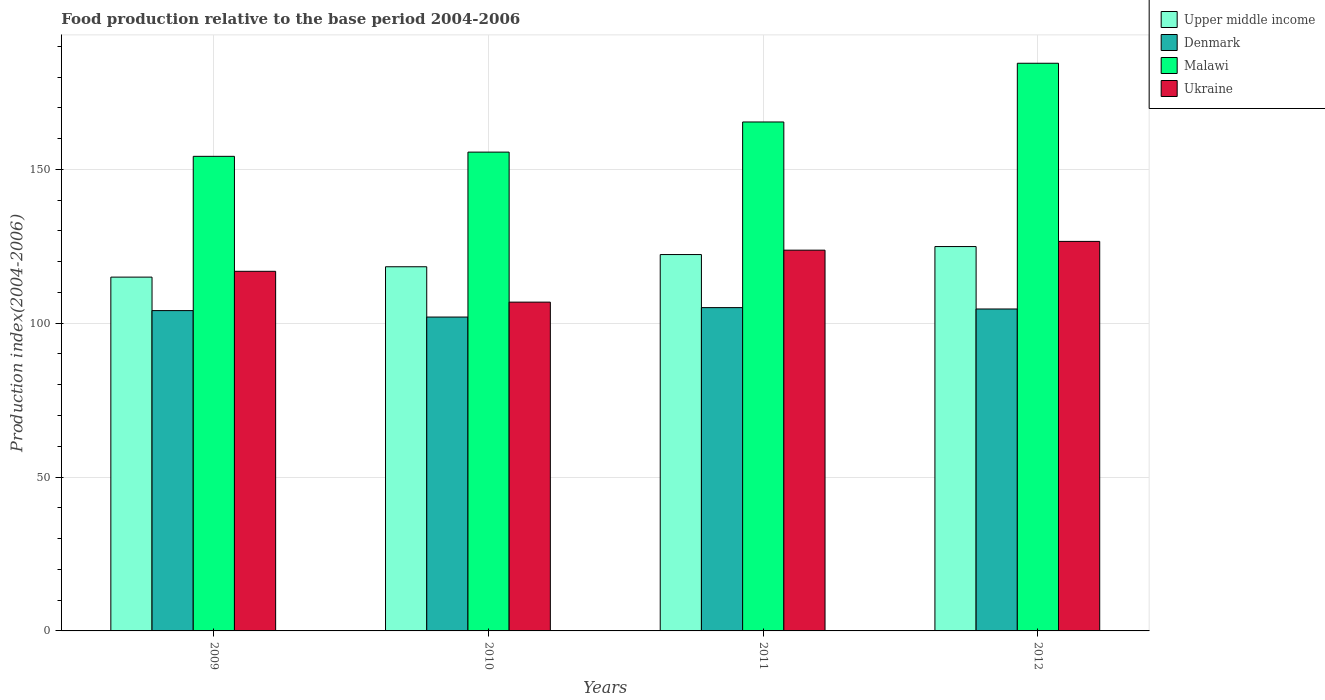How many different coloured bars are there?
Make the answer very short. 4. Are the number of bars per tick equal to the number of legend labels?
Your answer should be compact. Yes. How many bars are there on the 4th tick from the left?
Make the answer very short. 4. What is the label of the 3rd group of bars from the left?
Your answer should be very brief. 2011. What is the food production index in Denmark in 2010?
Your answer should be very brief. 102. Across all years, what is the maximum food production index in Malawi?
Give a very brief answer. 184.48. Across all years, what is the minimum food production index in Ukraine?
Provide a succinct answer. 106.85. In which year was the food production index in Denmark maximum?
Keep it short and to the point. 2011. What is the total food production index in Denmark in the graph?
Offer a very short reply. 415.79. What is the difference between the food production index in Upper middle income in 2009 and that in 2010?
Your response must be concise. -3.37. What is the difference between the food production index in Denmark in 2011 and the food production index in Ukraine in 2012?
Your answer should be compact. -21.52. What is the average food production index in Malawi per year?
Provide a short and direct response. 164.93. In the year 2009, what is the difference between the food production index in Denmark and food production index in Malawi?
Offer a terse response. -50.13. In how many years, is the food production index in Denmark greater than 160?
Keep it short and to the point. 0. What is the ratio of the food production index in Malawi in 2009 to that in 2010?
Offer a very short reply. 0.99. Is the food production index in Upper middle income in 2009 less than that in 2012?
Provide a succinct answer. Yes. What is the difference between the highest and the second highest food production index in Denmark?
Offer a terse response. 0.45. What is the difference between the highest and the lowest food production index in Denmark?
Offer a very short reply. 3.07. In how many years, is the food production index in Denmark greater than the average food production index in Denmark taken over all years?
Provide a succinct answer. 3. Is the sum of the food production index in Ukraine in 2009 and 2011 greater than the maximum food production index in Denmark across all years?
Your response must be concise. Yes. What does the 1st bar from the left in 2012 represents?
Provide a short and direct response. Upper middle income. What does the 1st bar from the right in 2010 represents?
Keep it short and to the point. Ukraine. Is it the case that in every year, the sum of the food production index in Upper middle income and food production index in Malawi is greater than the food production index in Ukraine?
Offer a very short reply. Yes. How many years are there in the graph?
Offer a terse response. 4. Are the values on the major ticks of Y-axis written in scientific E-notation?
Provide a succinct answer. No. Does the graph contain any zero values?
Provide a short and direct response. No. Where does the legend appear in the graph?
Offer a terse response. Top right. How many legend labels are there?
Ensure brevity in your answer.  4. What is the title of the graph?
Your answer should be compact. Food production relative to the base period 2004-2006. Does "Jamaica" appear as one of the legend labels in the graph?
Make the answer very short. No. What is the label or title of the X-axis?
Your answer should be compact. Years. What is the label or title of the Y-axis?
Provide a succinct answer. Production index(2004-2006). What is the Production index(2004-2006) of Upper middle income in 2009?
Offer a terse response. 114.98. What is the Production index(2004-2006) in Denmark in 2009?
Your answer should be compact. 104.1. What is the Production index(2004-2006) of Malawi in 2009?
Your answer should be very brief. 154.23. What is the Production index(2004-2006) in Ukraine in 2009?
Offer a terse response. 116.87. What is the Production index(2004-2006) in Upper middle income in 2010?
Make the answer very short. 118.35. What is the Production index(2004-2006) in Denmark in 2010?
Offer a terse response. 102. What is the Production index(2004-2006) of Malawi in 2010?
Offer a very short reply. 155.6. What is the Production index(2004-2006) of Ukraine in 2010?
Give a very brief answer. 106.85. What is the Production index(2004-2006) of Upper middle income in 2011?
Give a very brief answer. 122.31. What is the Production index(2004-2006) of Denmark in 2011?
Offer a terse response. 105.07. What is the Production index(2004-2006) of Malawi in 2011?
Provide a short and direct response. 165.4. What is the Production index(2004-2006) in Ukraine in 2011?
Your answer should be very brief. 123.74. What is the Production index(2004-2006) in Upper middle income in 2012?
Provide a short and direct response. 124.91. What is the Production index(2004-2006) in Denmark in 2012?
Offer a terse response. 104.62. What is the Production index(2004-2006) in Malawi in 2012?
Provide a succinct answer. 184.48. What is the Production index(2004-2006) in Ukraine in 2012?
Provide a short and direct response. 126.59. Across all years, what is the maximum Production index(2004-2006) of Upper middle income?
Your response must be concise. 124.91. Across all years, what is the maximum Production index(2004-2006) in Denmark?
Ensure brevity in your answer.  105.07. Across all years, what is the maximum Production index(2004-2006) in Malawi?
Your response must be concise. 184.48. Across all years, what is the maximum Production index(2004-2006) in Ukraine?
Offer a terse response. 126.59. Across all years, what is the minimum Production index(2004-2006) of Upper middle income?
Provide a succinct answer. 114.98. Across all years, what is the minimum Production index(2004-2006) in Denmark?
Your answer should be very brief. 102. Across all years, what is the minimum Production index(2004-2006) in Malawi?
Offer a terse response. 154.23. Across all years, what is the minimum Production index(2004-2006) of Ukraine?
Provide a short and direct response. 106.85. What is the total Production index(2004-2006) of Upper middle income in the graph?
Make the answer very short. 480.55. What is the total Production index(2004-2006) of Denmark in the graph?
Ensure brevity in your answer.  415.79. What is the total Production index(2004-2006) in Malawi in the graph?
Your answer should be compact. 659.71. What is the total Production index(2004-2006) in Ukraine in the graph?
Ensure brevity in your answer.  474.05. What is the difference between the Production index(2004-2006) in Upper middle income in 2009 and that in 2010?
Ensure brevity in your answer.  -3.37. What is the difference between the Production index(2004-2006) in Denmark in 2009 and that in 2010?
Provide a succinct answer. 2.1. What is the difference between the Production index(2004-2006) of Malawi in 2009 and that in 2010?
Give a very brief answer. -1.37. What is the difference between the Production index(2004-2006) of Ukraine in 2009 and that in 2010?
Your answer should be very brief. 10.02. What is the difference between the Production index(2004-2006) in Upper middle income in 2009 and that in 2011?
Offer a very short reply. -7.33. What is the difference between the Production index(2004-2006) in Denmark in 2009 and that in 2011?
Give a very brief answer. -0.97. What is the difference between the Production index(2004-2006) in Malawi in 2009 and that in 2011?
Offer a terse response. -11.17. What is the difference between the Production index(2004-2006) of Ukraine in 2009 and that in 2011?
Your answer should be very brief. -6.87. What is the difference between the Production index(2004-2006) of Upper middle income in 2009 and that in 2012?
Your response must be concise. -9.93. What is the difference between the Production index(2004-2006) in Denmark in 2009 and that in 2012?
Provide a succinct answer. -0.52. What is the difference between the Production index(2004-2006) of Malawi in 2009 and that in 2012?
Give a very brief answer. -30.25. What is the difference between the Production index(2004-2006) of Ukraine in 2009 and that in 2012?
Provide a short and direct response. -9.72. What is the difference between the Production index(2004-2006) of Upper middle income in 2010 and that in 2011?
Make the answer very short. -3.96. What is the difference between the Production index(2004-2006) in Denmark in 2010 and that in 2011?
Provide a short and direct response. -3.07. What is the difference between the Production index(2004-2006) of Malawi in 2010 and that in 2011?
Provide a short and direct response. -9.8. What is the difference between the Production index(2004-2006) in Ukraine in 2010 and that in 2011?
Give a very brief answer. -16.89. What is the difference between the Production index(2004-2006) of Upper middle income in 2010 and that in 2012?
Provide a succinct answer. -6.57. What is the difference between the Production index(2004-2006) in Denmark in 2010 and that in 2012?
Ensure brevity in your answer.  -2.62. What is the difference between the Production index(2004-2006) of Malawi in 2010 and that in 2012?
Your answer should be very brief. -28.88. What is the difference between the Production index(2004-2006) in Ukraine in 2010 and that in 2012?
Provide a short and direct response. -19.74. What is the difference between the Production index(2004-2006) in Upper middle income in 2011 and that in 2012?
Your answer should be compact. -2.6. What is the difference between the Production index(2004-2006) of Denmark in 2011 and that in 2012?
Make the answer very short. 0.45. What is the difference between the Production index(2004-2006) in Malawi in 2011 and that in 2012?
Your response must be concise. -19.08. What is the difference between the Production index(2004-2006) of Ukraine in 2011 and that in 2012?
Offer a very short reply. -2.85. What is the difference between the Production index(2004-2006) of Upper middle income in 2009 and the Production index(2004-2006) of Denmark in 2010?
Your answer should be compact. 12.98. What is the difference between the Production index(2004-2006) in Upper middle income in 2009 and the Production index(2004-2006) in Malawi in 2010?
Keep it short and to the point. -40.62. What is the difference between the Production index(2004-2006) in Upper middle income in 2009 and the Production index(2004-2006) in Ukraine in 2010?
Give a very brief answer. 8.13. What is the difference between the Production index(2004-2006) in Denmark in 2009 and the Production index(2004-2006) in Malawi in 2010?
Your answer should be very brief. -51.5. What is the difference between the Production index(2004-2006) of Denmark in 2009 and the Production index(2004-2006) of Ukraine in 2010?
Offer a very short reply. -2.75. What is the difference between the Production index(2004-2006) in Malawi in 2009 and the Production index(2004-2006) in Ukraine in 2010?
Offer a very short reply. 47.38. What is the difference between the Production index(2004-2006) in Upper middle income in 2009 and the Production index(2004-2006) in Denmark in 2011?
Your response must be concise. 9.91. What is the difference between the Production index(2004-2006) in Upper middle income in 2009 and the Production index(2004-2006) in Malawi in 2011?
Provide a succinct answer. -50.42. What is the difference between the Production index(2004-2006) in Upper middle income in 2009 and the Production index(2004-2006) in Ukraine in 2011?
Offer a very short reply. -8.76. What is the difference between the Production index(2004-2006) of Denmark in 2009 and the Production index(2004-2006) of Malawi in 2011?
Make the answer very short. -61.3. What is the difference between the Production index(2004-2006) of Denmark in 2009 and the Production index(2004-2006) of Ukraine in 2011?
Give a very brief answer. -19.64. What is the difference between the Production index(2004-2006) in Malawi in 2009 and the Production index(2004-2006) in Ukraine in 2011?
Offer a terse response. 30.49. What is the difference between the Production index(2004-2006) in Upper middle income in 2009 and the Production index(2004-2006) in Denmark in 2012?
Provide a short and direct response. 10.36. What is the difference between the Production index(2004-2006) of Upper middle income in 2009 and the Production index(2004-2006) of Malawi in 2012?
Your response must be concise. -69.5. What is the difference between the Production index(2004-2006) in Upper middle income in 2009 and the Production index(2004-2006) in Ukraine in 2012?
Keep it short and to the point. -11.61. What is the difference between the Production index(2004-2006) of Denmark in 2009 and the Production index(2004-2006) of Malawi in 2012?
Keep it short and to the point. -80.38. What is the difference between the Production index(2004-2006) of Denmark in 2009 and the Production index(2004-2006) of Ukraine in 2012?
Give a very brief answer. -22.49. What is the difference between the Production index(2004-2006) of Malawi in 2009 and the Production index(2004-2006) of Ukraine in 2012?
Ensure brevity in your answer.  27.64. What is the difference between the Production index(2004-2006) in Upper middle income in 2010 and the Production index(2004-2006) in Denmark in 2011?
Make the answer very short. 13.28. What is the difference between the Production index(2004-2006) of Upper middle income in 2010 and the Production index(2004-2006) of Malawi in 2011?
Your response must be concise. -47.05. What is the difference between the Production index(2004-2006) of Upper middle income in 2010 and the Production index(2004-2006) of Ukraine in 2011?
Offer a very short reply. -5.39. What is the difference between the Production index(2004-2006) of Denmark in 2010 and the Production index(2004-2006) of Malawi in 2011?
Keep it short and to the point. -63.4. What is the difference between the Production index(2004-2006) of Denmark in 2010 and the Production index(2004-2006) of Ukraine in 2011?
Offer a very short reply. -21.74. What is the difference between the Production index(2004-2006) of Malawi in 2010 and the Production index(2004-2006) of Ukraine in 2011?
Give a very brief answer. 31.86. What is the difference between the Production index(2004-2006) in Upper middle income in 2010 and the Production index(2004-2006) in Denmark in 2012?
Your response must be concise. 13.73. What is the difference between the Production index(2004-2006) of Upper middle income in 2010 and the Production index(2004-2006) of Malawi in 2012?
Your response must be concise. -66.13. What is the difference between the Production index(2004-2006) of Upper middle income in 2010 and the Production index(2004-2006) of Ukraine in 2012?
Ensure brevity in your answer.  -8.24. What is the difference between the Production index(2004-2006) in Denmark in 2010 and the Production index(2004-2006) in Malawi in 2012?
Give a very brief answer. -82.48. What is the difference between the Production index(2004-2006) of Denmark in 2010 and the Production index(2004-2006) of Ukraine in 2012?
Provide a short and direct response. -24.59. What is the difference between the Production index(2004-2006) of Malawi in 2010 and the Production index(2004-2006) of Ukraine in 2012?
Offer a terse response. 29.01. What is the difference between the Production index(2004-2006) of Upper middle income in 2011 and the Production index(2004-2006) of Denmark in 2012?
Provide a short and direct response. 17.69. What is the difference between the Production index(2004-2006) in Upper middle income in 2011 and the Production index(2004-2006) in Malawi in 2012?
Offer a very short reply. -62.17. What is the difference between the Production index(2004-2006) in Upper middle income in 2011 and the Production index(2004-2006) in Ukraine in 2012?
Provide a succinct answer. -4.28. What is the difference between the Production index(2004-2006) of Denmark in 2011 and the Production index(2004-2006) of Malawi in 2012?
Keep it short and to the point. -79.41. What is the difference between the Production index(2004-2006) of Denmark in 2011 and the Production index(2004-2006) of Ukraine in 2012?
Give a very brief answer. -21.52. What is the difference between the Production index(2004-2006) of Malawi in 2011 and the Production index(2004-2006) of Ukraine in 2012?
Give a very brief answer. 38.81. What is the average Production index(2004-2006) in Upper middle income per year?
Your answer should be very brief. 120.14. What is the average Production index(2004-2006) of Denmark per year?
Provide a succinct answer. 103.95. What is the average Production index(2004-2006) in Malawi per year?
Your answer should be compact. 164.93. What is the average Production index(2004-2006) of Ukraine per year?
Keep it short and to the point. 118.51. In the year 2009, what is the difference between the Production index(2004-2006) of Upper middle income and Production index(2004-2006) of Denmark?
Offer a very short reply. 10.88. In the year 2009, what is the difference between the Production index(2004-2006) in Upper middle income and Production index(2004-2006) in Malawi?
Provide a short and direct response. -39.25. In the year 2009, what is the difference between the Production index(2004-2006) of Upper middle income and Production index(2004-2006) of Ukraine?
Your answer should be compact. -1.89. In the year 2009, what is the difference between the Production index(2004-2006) of Denmark and Production index(2004-2006) of Malawi?
Provide a short and direct response. -50.13. In the year 2009, what is the difference between the Production index(2004-2006) of Denmark and Production index(2004-2006) of Ukraine?
Keep it short and to the point. -12.77. In the year 2009, what is the difference between the Production index(2004-2006) of Malawi and Production index(2004-2006) of Ukraine?
Ensure brevity in your answer.  37.36. In the year 2010, what is the difference between the Production index(2004-2006) in Upper middle income and Production index(2004-2006) in Denmark?
Offer a terse response. 16.35. In the year 2010, what is the difference between the Production index(2004-2006) in Upper middle income and Production index(2004-2006) in Malawi?
Give a very brief answer. -37.25. In the year 2010, what is the difference between the Production index(2004-2006) in Upper middle income and Production index(2004-2006) in Ukraine?
Your answer should be very brief. 11.5. In the year 2010, what is the difference between the Production index(2004-2006) in Denmark and Production index(2004-2006) in Malawi?
Your answer should be compact. -53.6. In the year 2010, what is the difference between the Production index(2004-2006) of Denmark and Production index(2004-2006) of Ukraine?
Your answer should be very brief. -4.85. In the year 2010, what is the difference between the Production index(2004-2006) in Malawi and Production index(2004-2006) in Ukraine?
Give a very brief answer. 48.75. In the year 2011, what is the difference between the Production index(2004-2006) of Upper middle income and Production index(2004-2006) of Denmark?
Your answer should be compact. 17.24. In the year 2011, what is the difference between the Production index(2004-2006) of Upper middle income and Production index(2004-2006) of Malawi?
Offer a very short reply. -43.09. In the year 2011, what is the difference between the Production index(2004-2006) of Upper middle income and Production index(2004-2006) of Ukraine?
Give a very brief answer. -1.43. In the year 2011, what is the difference between the Production index(2004-2006) in Denmark and Production index(2004-2006) in Malawi?
Offer a terse response. -60.33. In the year 2011, what is the difference between the Production index(2004-2006) in Denmark and Production index(2004-2006) in Ukraine?
Give a very brief answer. -18.67. In the year 2011, what is the difference between the Production index(2004-2006) in Malawi and Production index(2004-2006) in Ukraine?
Give a very brief answer. 41.66. In the year 2012, what is the difference between the Production index(2004-2006) of Upper middle income and Production index(2004-2006) of Denmark?
Your response must be concise. 20.29. In the year 2012, what is the difference between the Production index(2004-2006) in Upper middle income and Production index(2004-2006) in Malawi?
Your response must be concise. -59.57. In the year 2012, what is the difference between the Production index(2004-2006) in Upper middle income and Production index(2004-2006) in Ukraine?
Offer a terse response. -1.68. In the year 2012, what is the difference between the Production index(2004-2006) in Denmark and Production index(2004-2006) in Malawi?
Your answer should be compact. -79.86. In the year 2012, what is the difference between the Production index(2004-2006) in Denmark and Production index(2004-2006) in Ukraine?
Offer a very short reply. -21.97. In the year 2012, what is the difference between the Production index(2004-2006) of Malawi and Production index(2004-2006) of Ukraine?
Give a very brief answer. 57.89. What is the ratio of the Production index(2004-2006) in Upper middle income in 2009 to that in 2010?
Ensure brevity in your answer.  0.97. What is the ratio of the Production index(2004-2006) of Denmark in 2009 to that in 2010?
Your response must be concise. 1.02. What is the ratio of the Production index(2004-2006) in Ukraine in 2009 to that in 2010?
Ensure brevity in your answer.  1.09. What is the ratio of the Production index(2004-2006) of Upper middle income in 2009 to that in 2011?
Offer a terse response. 0.94. What is the ratio of the Production index(2004-2006) of Denmark in 2009 to that in 2011?
Offer a very short reply. 0.99. What is the ratio of the Production index(2004-2006) in Malawi in 2009 to that in 2011?
Your answer should be compact. 0.93. What is the ratio of the Production index(2004-2006) in Ukraine in 2009 to that in 2011?
Your answer should be very brief. 0.94. What is the ratio of the Production index(2004-2006) in Upper middle income in 2009 to that in 2012?
Ensure brevity in your answer.  0.92. What is the ratio of the Production index(2004-2006) of Malawi in 2009 to that in 2012?
Offer a very short reply. 0.84. What is the ratio of the Production index(2004-2006) of Ukraine in 2009 to that in 2012?
Your answer should be compact. 0.92. What is the ratio of the Production index(2004-2006) in Upper middle income in 2010 to that in 2011?
Your answer should be very brief. 0.97. What is the ratio of the Production index(2004-2006) in Denmark in 2010 to that in 2011?
Offer a terse response. 0.97. What is the ratio of the Production index(2004-2006) of Malawi in 2010 to that in 2011?
Give a very brief answer. 0.94. What is the ratio of the Production index(2004-2006) of Ukraine in 2010 to that in 2011?
Provide a short and direct response. 0.86. What is the ratio of the Production index(2004-2006) of Upper middle income in 2010 to that in 2012?
Give a very brief answer. 0.95. What is the ratio of the Production index(2004-2006) of Denmark in 2010 to that in 2012?
Your answer should be compact. 0.97. What is the ratio of the Production index(2004-2006) of Malawi in 2010 to that in 2012?
Ensure brevity in your answer.  0.84. What is the ratio of the Production index(2004-2006) of Ukraine in 2010 to that in 2012?
Ensure brevity in your answer.  0.84. What is the ratio of the Production index(2004-2006) in Upper middle income in 2011 to that in 2012?
Give a very brief answer. 0.98. What is the ratio of the Production index(2004-2006) of Denmark in 2011 to that in 2012?
Provide a succinct answer. 1. What is the ratio of the Production index(2004-2006) of Malawi in 2011 to that in 2012?
Offer a terse response. 0.9. What is the ratio of the Production index(2004-2006) in Ukraine in 2011 to that in 2012?
Your response must be concise. 0.98. What is the difference between the highest and the second highest Production index(2004-2006) of Upper middle income?
Provide a succinct answer. 2.6. What is the difference between the highest and the second highest Production index(2004-2006) of Denmark?
Your answer should be compact. 0.45. What is the difference between the highest and the second highest Production index(2004-2006) of Malawi?
Keep it short and to the point. 19.08. What is the difference between the highest and the second highest Production index(2004-2006) in Ukraine?
Your response must be concise. 2.85. What is the difference between the highest and the lowest Production index(2004-2006) of Upper middle income?
Offer a terse response. 9.93. What is the difference between the highest and the lowest Production index(2004-2006) in Denmark?
Provide a succinct answer. 3.07. What is the difference between the highest and the lowest Production index(2004-2006) in Malawi?
Make the answer very short. 30.25. What is the difference between the highest and the lowest Production index(2004-2006) in Ukraine?
Give a very brief answer. 19.74. 